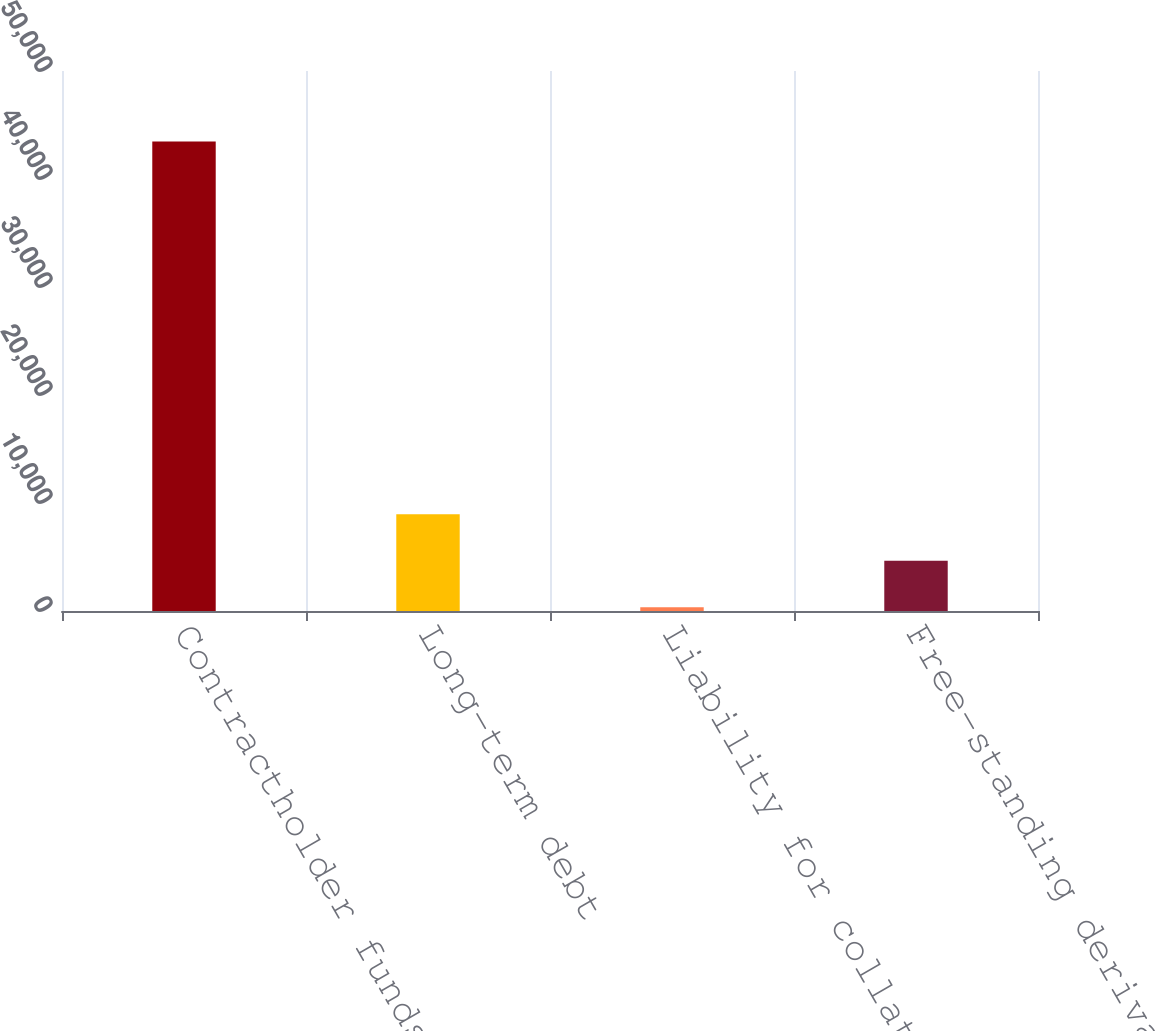Convert chart to OTSL. <chart><loc_0><loc_0><loc_500><loc_500><bar_chart><fcel>Contractholder funds on<fcel>Long-term debt<fcel>Liability for collateral<fcel>Free-standing derivatives<nl><fcel>43479<fcel>8967.8<fcel>340<fcel>4653.9<nl></chart> 